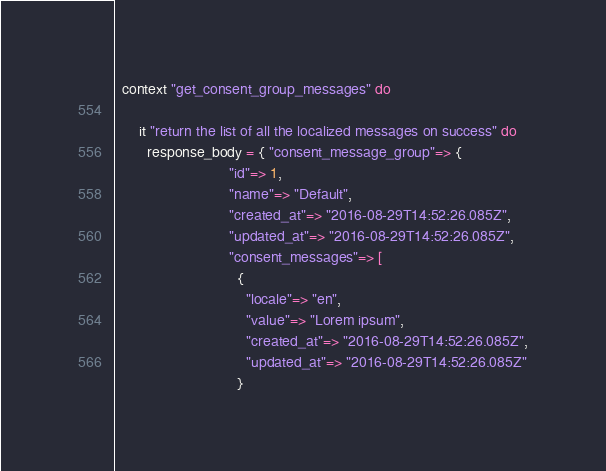Convert code to text. <code><loc_0><loc_0><loc_500><loc_500><_Ruby_>  context "get_consent_group_messages" do

      it "return the list of all the localized messages on success" do
        response_body = { "consent_message_group"=> {
                            "id"=> 1,
                            "name"=> "Default",
                            "created_at"=> "2016-08-29T14:52:26.085Z",
                            "updated_at"=> "2016-08-29T14:52:26.085Z",
                            "consent_messages"=> [
                              {
                                "locale"=> "en",
                                "value"=> "Lorem ipsum",
                                "created_at"=> "2016-08-29T14:52:26.085Z",
                                "updated_at"=> "2016-08-29T14:52:26.085Z"
                              }</code> 